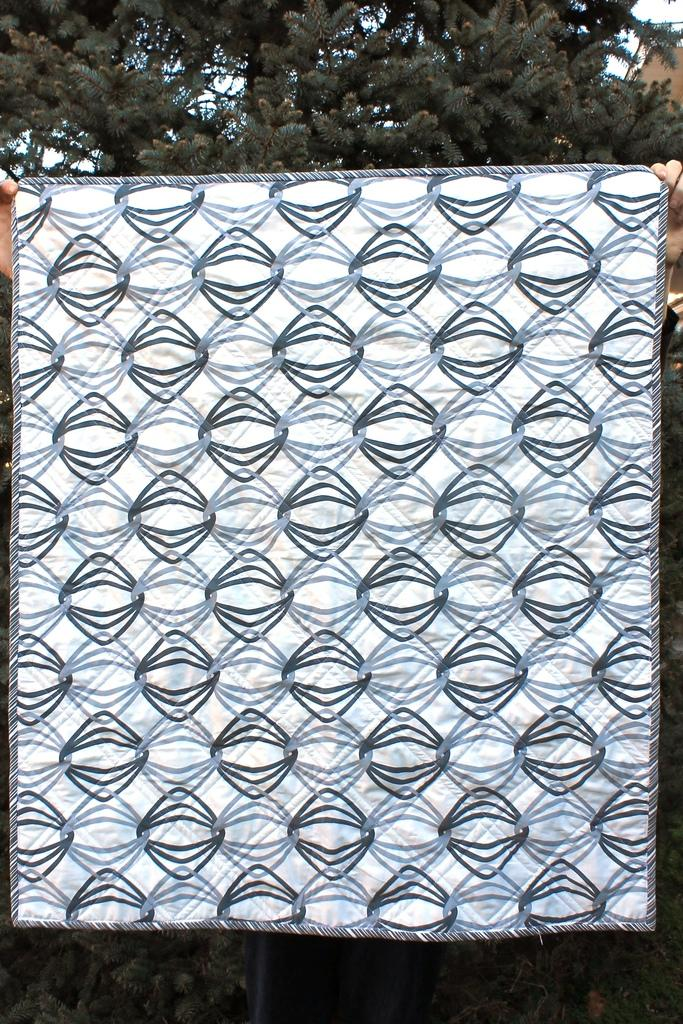What is the main subject of the picture? There is a person in the picture. What is the person holding in the image? The person is holding a cloth. Can you describe the cloth in the image? The cloth has designs on it. What can be seen in the background of the image? There are trees in the background of the image. What type of sign can be seen in the image? There is no sign present in the image; it features a person holding a cloth with designs. What type of vacation is the person planning in the image? There is no indication of a vacation in the image; it simply shows a person holding a cloth with designs. 